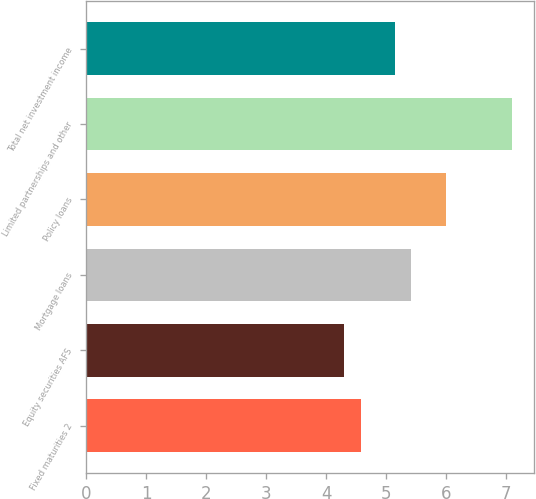<chart> <loc_0><loc_0><loc_500><loc_500><bar_chart><fcel>Fixed maturities 2<fcel>Equity securities AFS<fcel>Mortgage loans<fcel>Policy loans<fcel>Limited partnerships and other<fcel>Total net investment income<nl><fcel>4.58<fcel>4.3<fcel>5.42<fcel>6<fcel>7.1<fcel>5.14<nl></chart> 